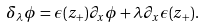<formula> <loc_0><loc_0><loc_500><loc_500>\delta _ { \lambda } \phi = \epsilon ( z _ { + } ) \partial _ { x } \phi + \lambda \partial _ { x } \epsilon ( z _ { + } ) .</formula> 